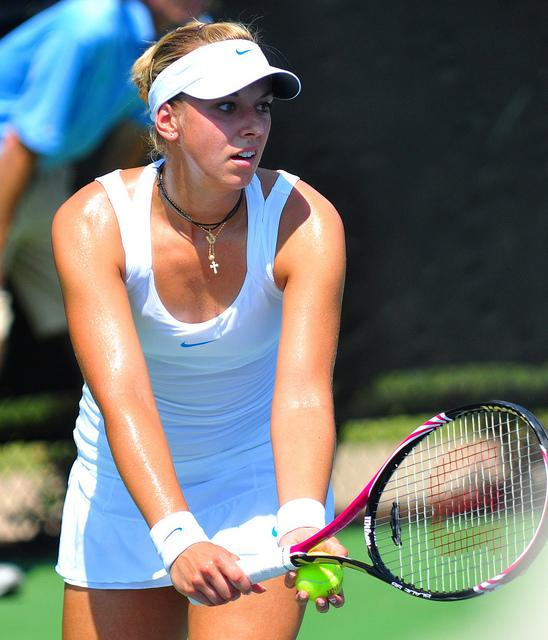When an athlete starts to overheat and sweat starts pouring there body is asking for what to replenish it? Please explain your reasoning. water. The body will be thirsty. 